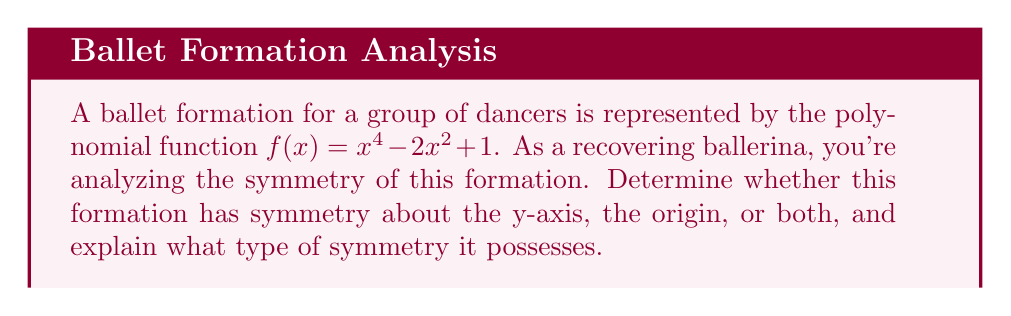Could you help me with this problem? To analyze the symmetry of the ballet formation represented by $f(x) = x^4 - 2x^2 + 1$, we need to examine the properties of even and odd functions:

1. Even function: $f(-x) = f(x)$ (symmetric about y-axis)
2. Odd function: $f(-x) = -f(x)$ (symmetric about origin)

Let's check for even symmetry:
$f(-x) = (-x)^4 - 2(-x)^2 + 1$
$= x^4 - 2x^2 + 1$
$= f(x)$

Since $f(-x) = f(x)$, the function is even, which means it's symmetric about the y-axis.

To verify odd symmetry:
$f(-x) = x^4 - 2x^2 + 1$
$-f(x) = -(x^4 - 2x^2 + 1) = -x^4 + 2x^2 - 1$

Since $f(-x) \neq -f(x)$, the function is not odd and does not have symmetry about the origin.

Additionally, we can observe that this function only contains even powers of x (4 and 2), which is a characteristic of even functions.

In terms of the ballet formation, this means that the dancers' positions will be mirrored on either side of the center line (y-axis) of the stage, creating a balanced and visually appealing arrangement.
Answer: The formation has y-axis symmetry (even function). 